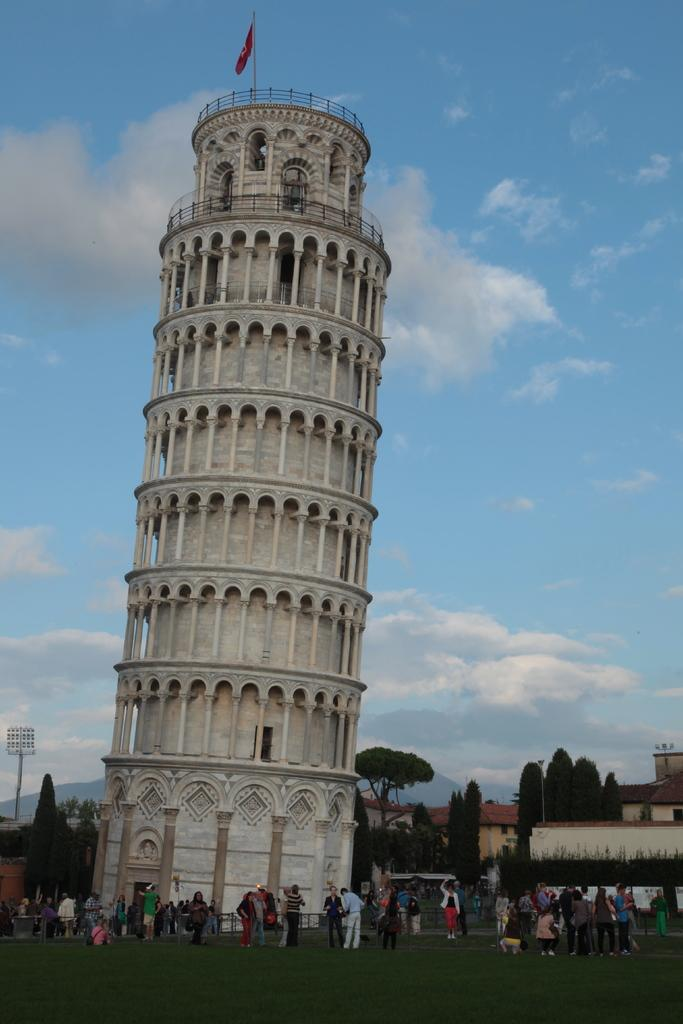What famous landmark is in the image? The Leaning Tower of Pisa is in the image. What type of natural elements can be seen in the image? There are trees in the image. What can be observed on the ground in the image? There are people on the ground in the image. What is visible in the sky in the background of the image? There are clouds visible in the sky in the background of the image. What type of ring can be seen on the chin of the person in the image? There is no person with a ring on their chin in the image; it only features the Leaning Tower of Pisa, trees, people on the ground, and clouds in the sky. 